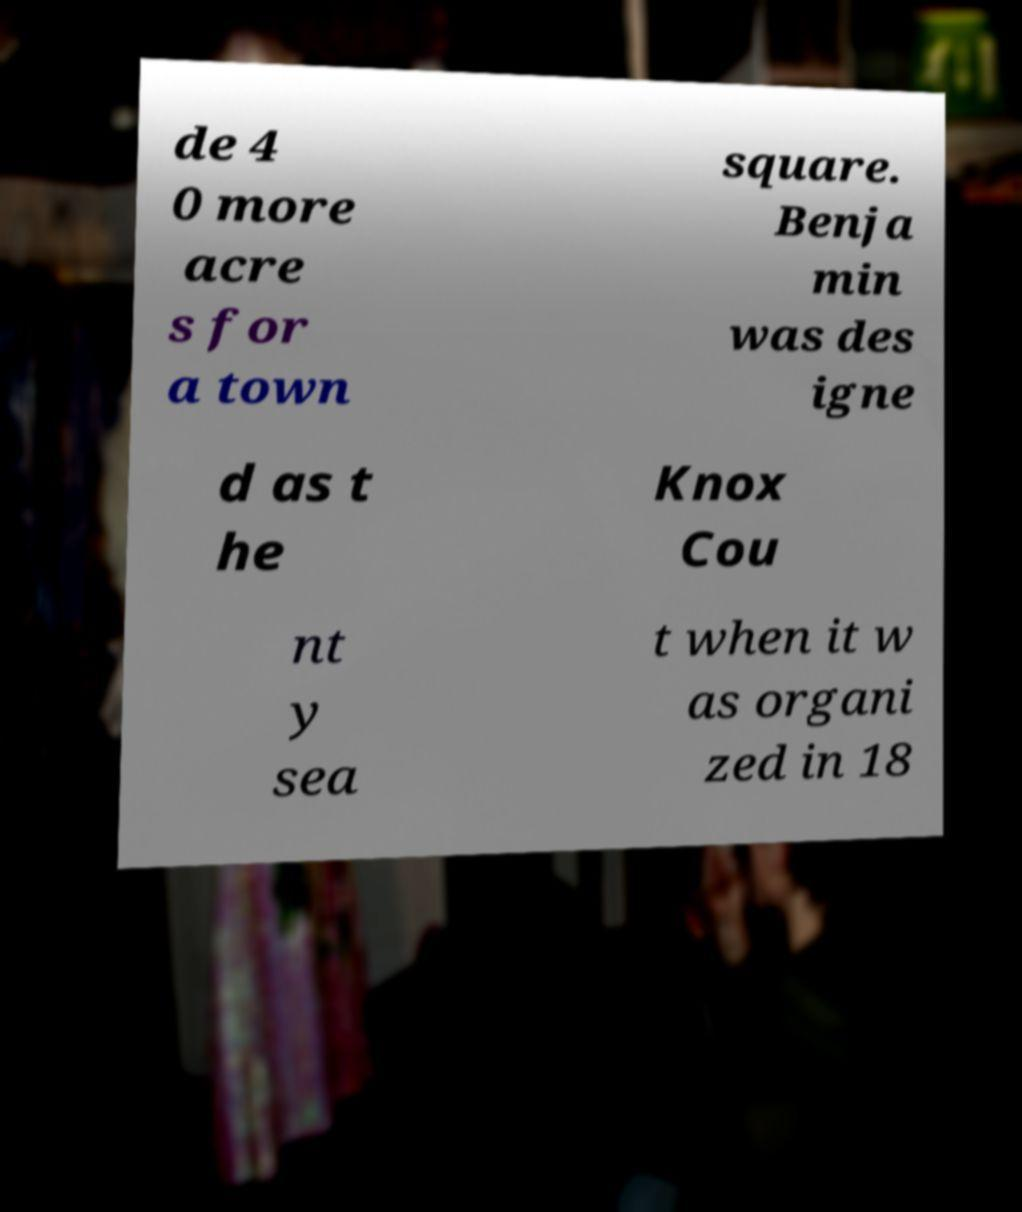Can you accurately transcribe the text from the provided image for me? de 4 0 more acre s for a town square. Benja min was des igne d as t he Knox Cou nt y sea t when it w as organi zed in 18 